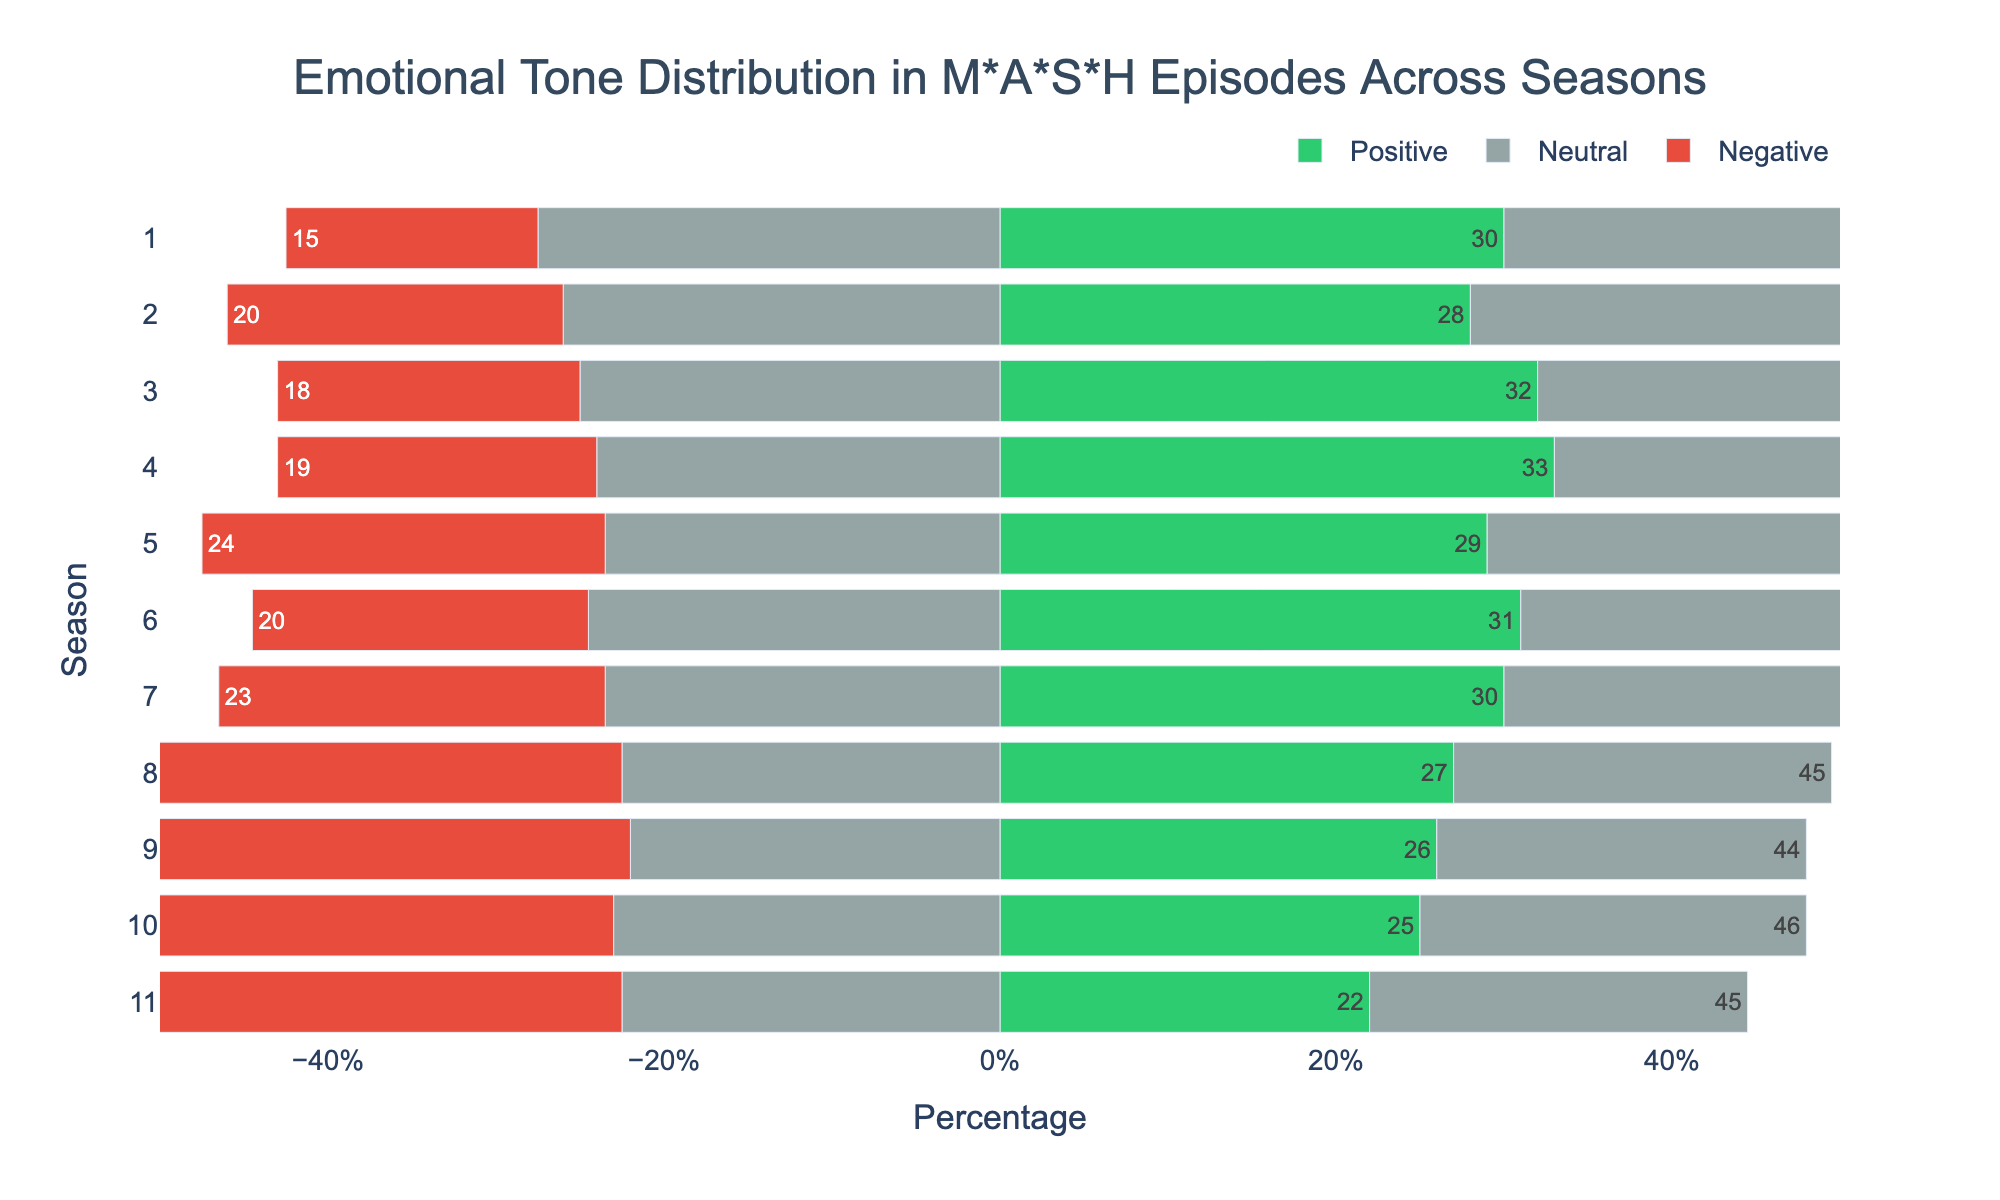Which season has the highest percentage of positive emotional tone? Look at the bar chart for the season with the green bar extending the furthest to the right. Season 4 has the longest green bar, indicating the highest percentage of positive emotional tone.
Answer: Season 4 How does the percentage of neutral emotional tone in Season 1 compare to Season 11? Add the lengths of the gray bars on either side of the neutral midpoint for Seasons 1 and 11. Season 1 has a neutral tone of 55%, while Season 11 has a neutral tone of 45%.
Answer: Season 1 has a higher percentage of neutral emotional tone than Season 11 What is the trend in the percentage of negative emotional tone from Season 8 to Season 11? Observe the red bars representing negative emotional tone, noting how they increase or decrease from Season 8 to 11. The percentage of negative tone increases from 28% in Season 8 to 33% in Season 11.
Answer: The percentage of negative tone increases Which season has the lowest percentage of positive emotional tone, and what is it? Identify the season with the shortest green bar on the right side. Season 11 has the shortest green bar, which corresponds to 22%.
Answer: Season 11 with 22% Compare the positive and negative emotional tones in Season 5. Look at the lengths of the red and green bars for Season 5. The green bar represents 29% (positive), and the red bar represents 24% (negative).
Answer: Positive tone is higher What seasons have a negative emotional tone of 30% or more? Identify the seasons with red bars extending to 30% or further to the left. Seasons 9, 10, and 11 have a negative emotional tone of 30%, 29%, and 33%, respectively.
Answer: Seasons 9 and 11 Calculate the combined percentage of positive and negative emotional tones in Season 6. Add the percentages of the positive and negative tones in Season 6. The positive tone is 31%, and the negative tone is 20%. Therefore, combined, they are 31% + 20% = 51%.
Answer: 51% What is the difference between the highest and lowest percentages of neutral emotional tone across all seasons? Identify the highest and lowest neutral tones from the gray bars. The highest is 55% in Season 1, and the lowest is 44% in Season 9. Difference = 55% - 44% = 11%.
Answer: 11% Which season has the most balanced distribution of positive, neutral, and negative tones? Look for the season where the sizes of the green, gray, and red bars are most similar. Season 8 has a balanced distribution with 27% positive, 45% neutral, and 28% negative.
Answer: Season 8 